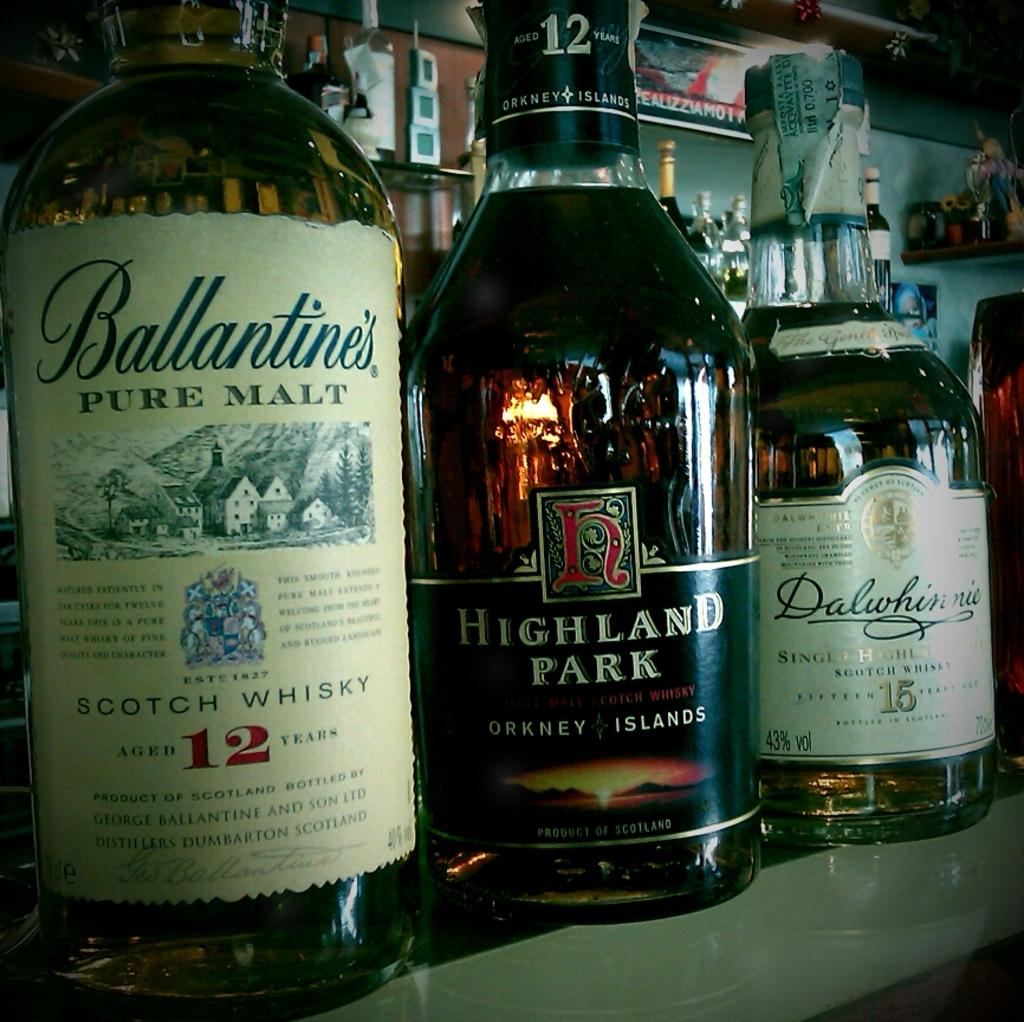What is the brand on the bottle in the middle?
Give a very brief answer. Highland park. 